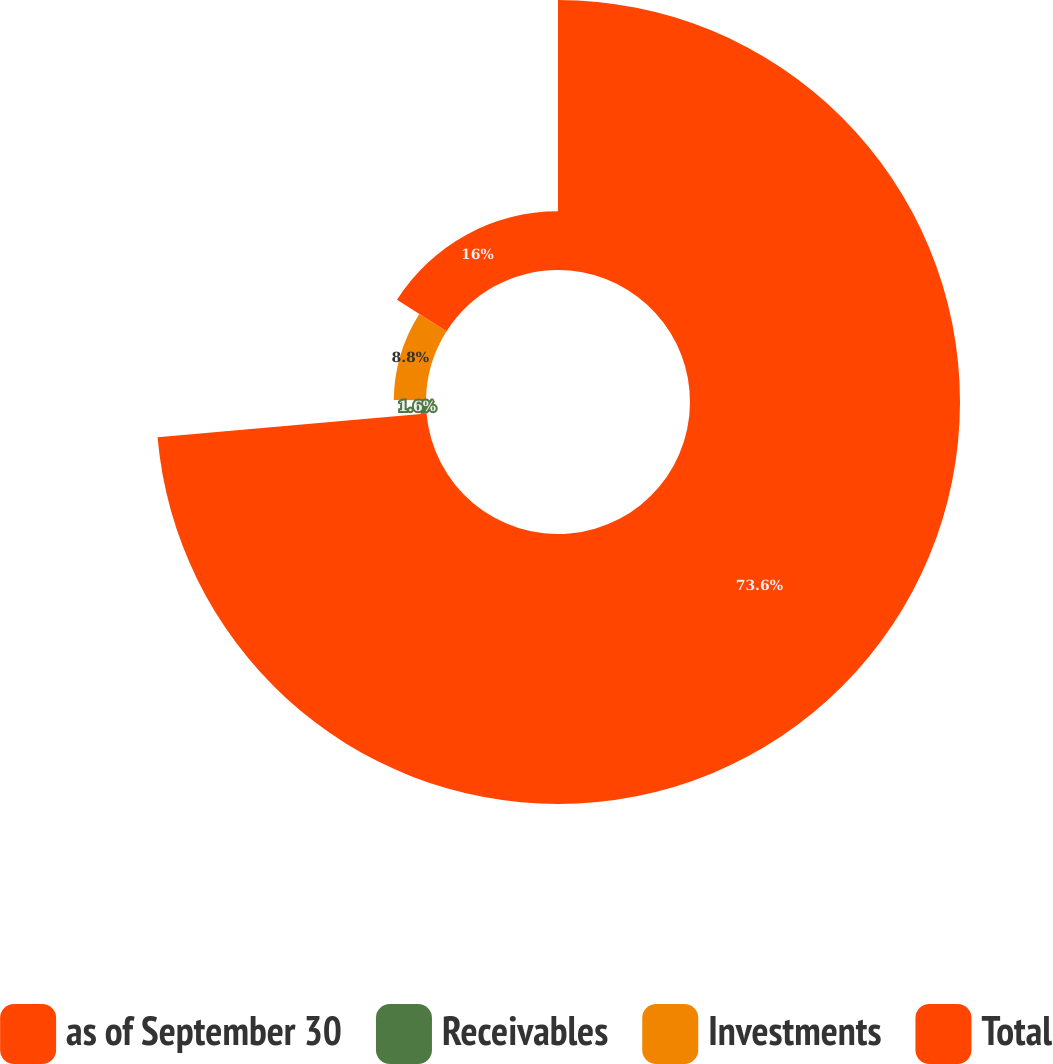Convert chart to OTSL. <chart><loc_0><loc_0><loc_500><loc_500><pie_chart><fcel>as of September 30<fcel>Receivables<fcel>Investments<fcel>Total<nl><fcel>73.6%<fcel>1.6%<fcel>8.8%<fcel>16.0%<nl></chart> 